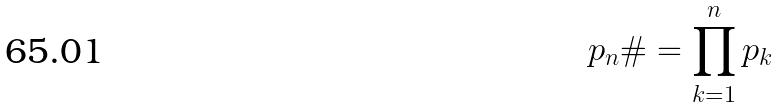Convert formula to latex. <formula><loc_0><loc_0><loc_500><loc_500>p _ { n } \# = \prod _ { k = 1 } ^ { n } p _ { k }</formula> 